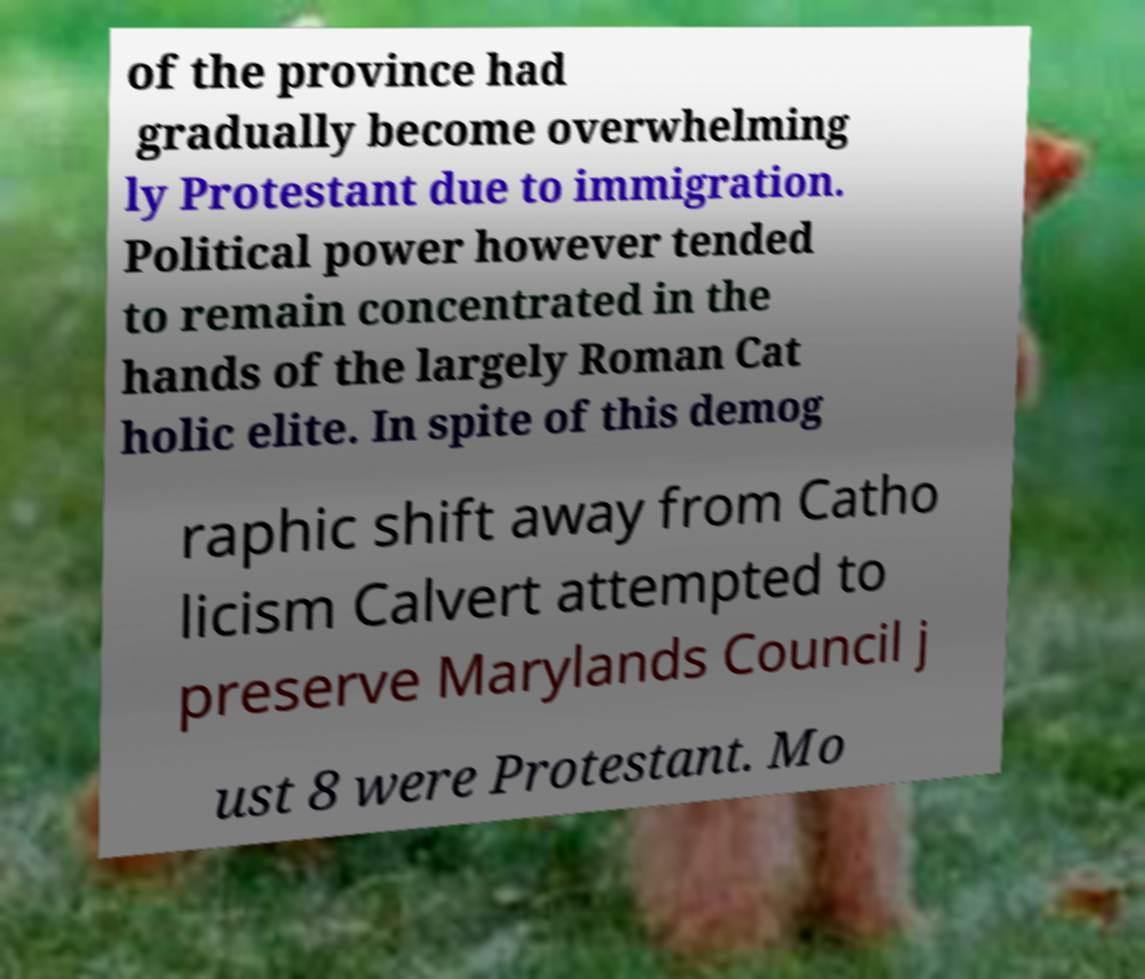Can you read and provide the text displayed in the image?This photo seems to have some interesting text. Can you extract and type it out for me? of the province had gradually become overwhelming ly Protestant due to immigration. Political power however tended to remain concentrated in the hands of the largely Roman Cat holic elite. In spite of this demog raphic shift away from Catho licism Calvert attempted to preserve Marylands Council j ust 8 were Protestant. Mo 